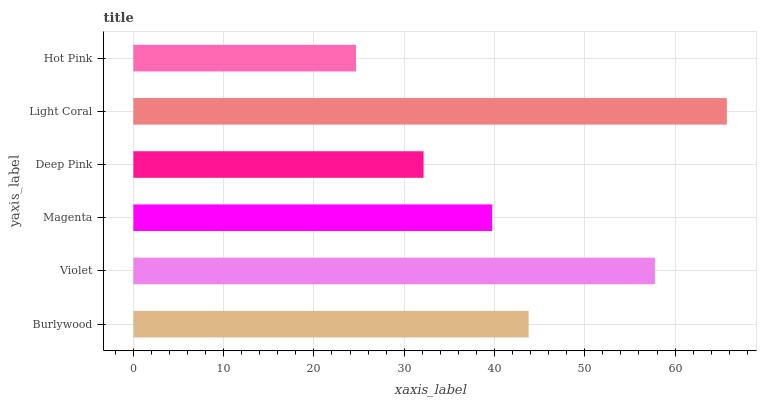Is Hot Pink the minimum?
Answer yes or no. Yes. Is Light Coral the maximum?
Answer yes or no. Yes. Is Violet the minimum?
Answer yes or no. No. Is Violet the maximum?
Answer yes or no. No. Is Violet greater than Burlywood?
Answer yes or no. Yes. Is Burlywood less than Violet?
Answer yes or no. Yes. Is Burlywood greater than Violet?
Answer yes or no. No. Is Violet less than Burlywood?
Answer yes or no. No. Is Burlywood the high median?
Answer yes or no. Yes. Is Magenta the low median?
Answer yes or no. Yes. Is Violet the high median?
Answer yes or no. No. Is Hot Pink the low median?
Answer yes or no. No. 